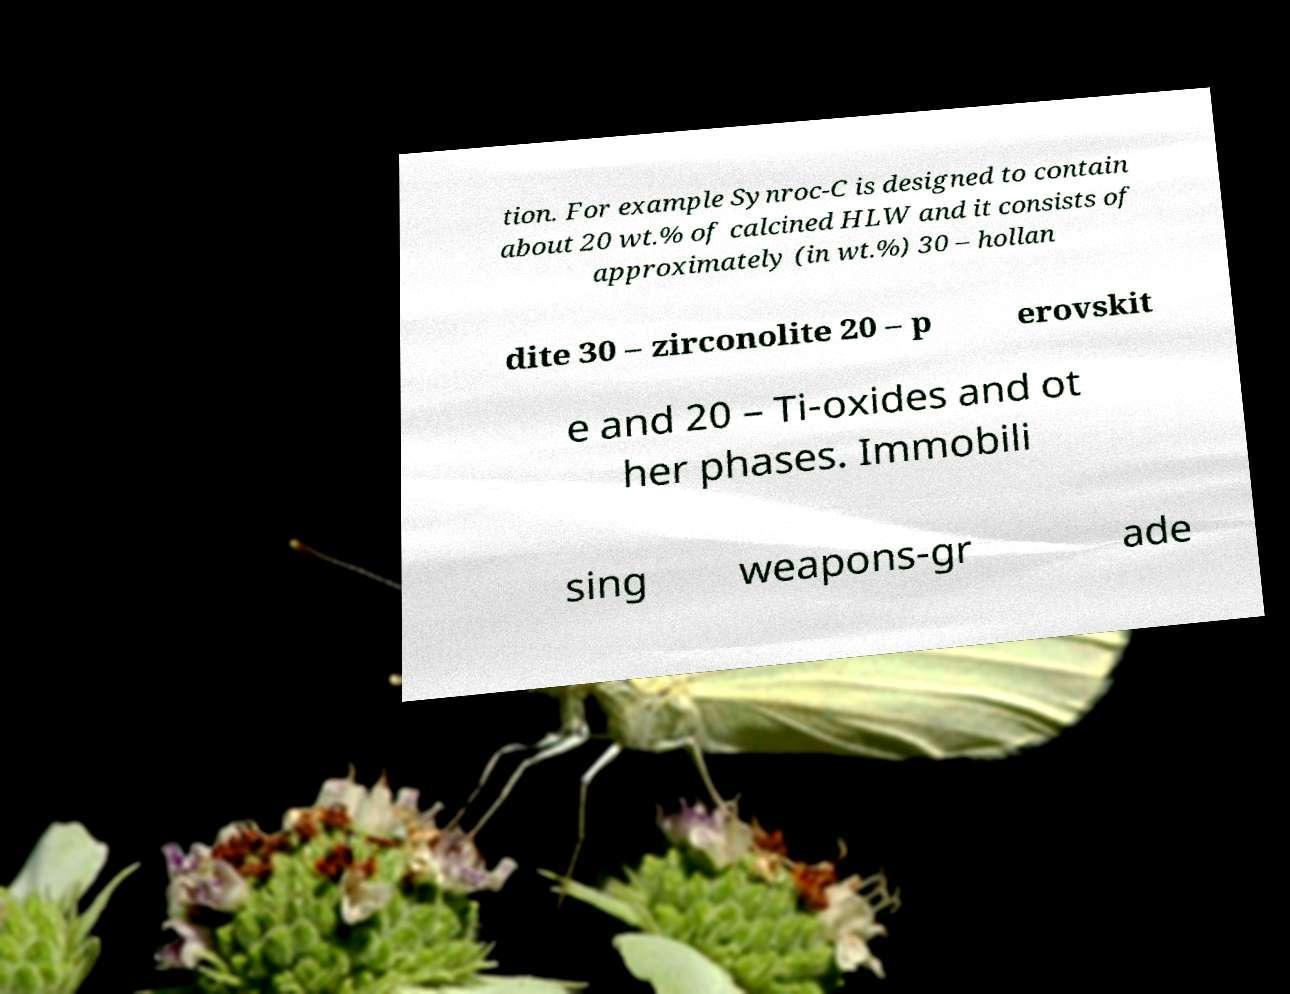Could you assist in decoding the text presented in this image and type it out clearly? tion. For example Synroc-C is designed to contain about 20 wt.% of calcined HLW and it consists of approximately (in wt.%) 30 – hollan dite 30 – zirconolite 20 – p erovskit e and 20 – Ti-oxides and ot her phases. Immobili sing weapons-gr ade 